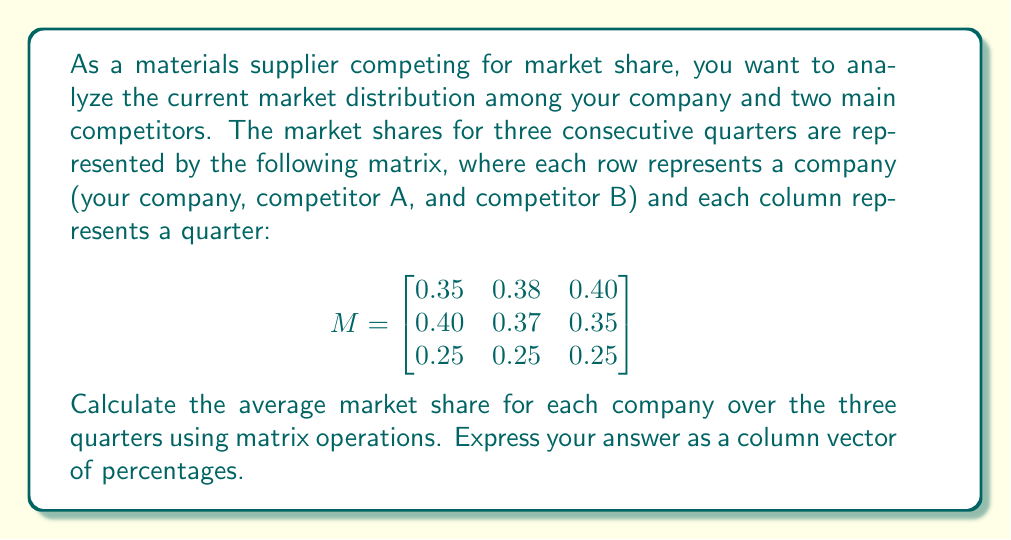Can you answer this question? To solve this problem, we need to follow these steps:

1) First, we need to calculate the average market share for each company. This can be done by summing the rows of the matrix and dividing by the number of columns (quarters).

2) We can achieve this using matrix multiplication. We'll multiply our matrix $M$ by a column vector of 1/3:

   $$\begin{bmatrix}
   0.35 & 0.38 & 0.40 \\
   0.40 & 0.37 & 0.35 \\
   0.25 & 0.25 & 0.25
   \end{bmatrix} \times \begin{bmatrix}
   1/3 \\
   1/3 \\
   1/3
   \end{bmatrix}$$

3) Let's perform the multiplication:

   For the first row: $(0.35 \times 1/3) + (0.38 \times 1/3) + (0.40 \times 1/3) = 0.3767$

   For the second row: $(0.40 \times 1/3) + (0.37 \times 1/3) + (0.35 \times 1/3) = 0.3733$

   For the third row: $(0.25 \times 1/3) + (0.25 \times 1/3) + (0.25 \times 1/3) = 0.2500$

4) This gives us a column vector of average market shares:

   $$\begin{bmatrix}
   0.3767 \\
   0.3733 \\
   0.2500
   \end{bmatrix}$$

5) To express these as percentages, we multiply each value by 100:

   $$\begin{bmatrix}
   37.67\% \\
   37.33\% \\
   25.00\%
   \end{bmatrix}$$
Answer: The average market shares over the three quarters, expressed as percentages, are:

$$\begin{bmatrix}
37.67\% \\
37.33\% \\
25.00\%
\end{bmatrix}$$

Where the first row represents your company, the second row represents competitor A, and the third row represents competitor B. 